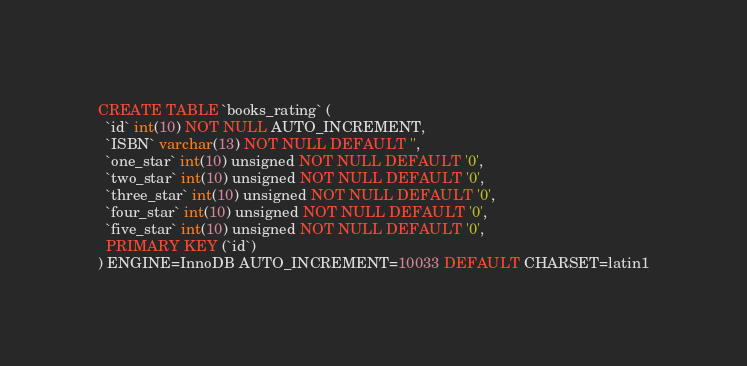Convert code to text. <code><loc_0><loc_0><loc_500><loc_500><_SQL_>
CREATE TABLE `books_rating` (
  `id` int(10) NOT NULL AUTO_INCREMENT,
  `ISBN` varchar(13) NOT NULL DEFAULT '',
  `one_star` int(10) unsigned NOT NULL DEFAULT '0',
  `two_star` int(10) unsigned NOT NULL DEFAULT '0',
  `three_star` int(10) unsigned NOT NULL DEFAULT '0',
  `four_star` int(10) unsigned NOT NULL DEFAULT '0',
  `five_star` int(10) unsigned NOT NULL DEFAULT '0',
  PRIMARY KEY (`id`)
) ENGINE=InnoDB AUTO_INCREMENT=10033 DEFAULT CHARSET=latin1</code> 